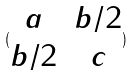<formula> <loc_0><loc_0><loc_500><loc_500>( \begin{matrix} a & b / 2 \\ b / 2 & c \end{matrix} )</formula> 